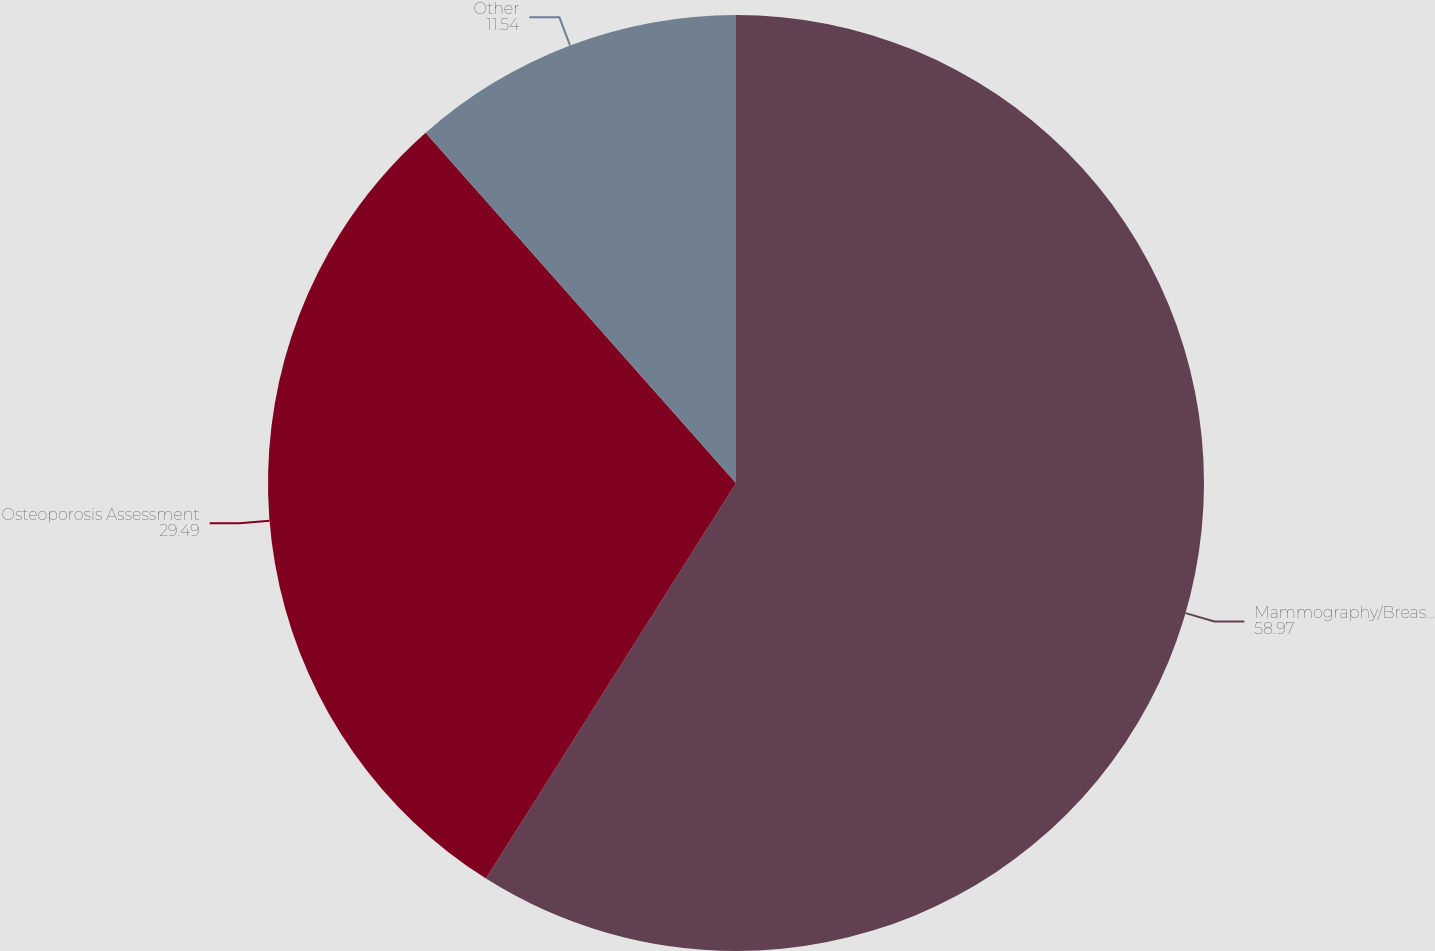<chart> <loc_0><loc_0><loc_500><loc_500><pie_chart><fcel>Mammography/Breast Care<fcel>Osteoporosis Assessment<fcel>Other<nl><fcel>58.97%<fcel>29.49%<fcel>11.54%<nl></chart> 